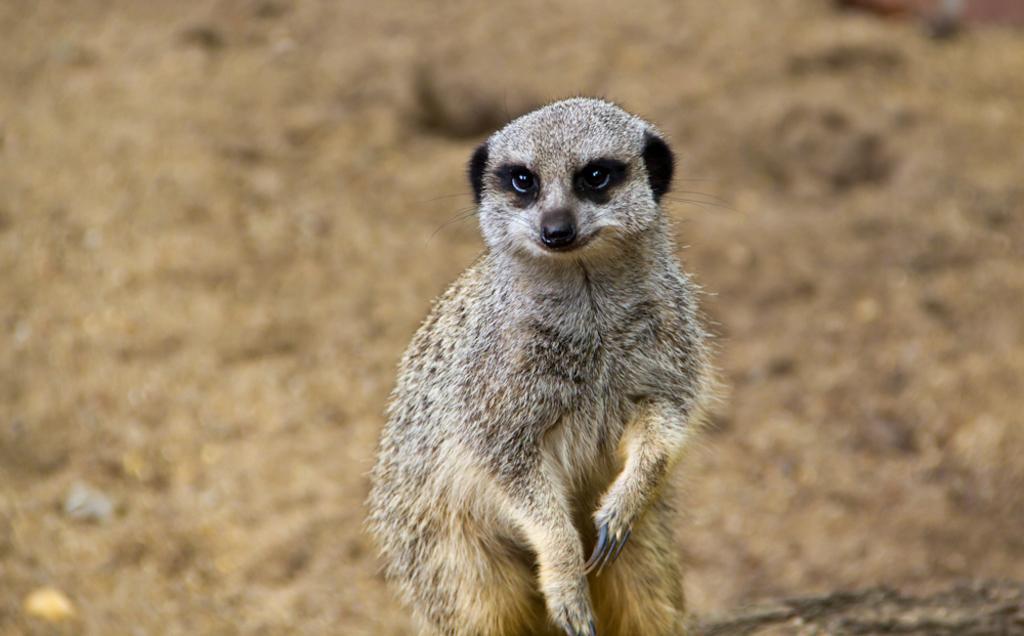Please provide a concise description of this image. In this picture I can see a meerkat and a blurry background. 